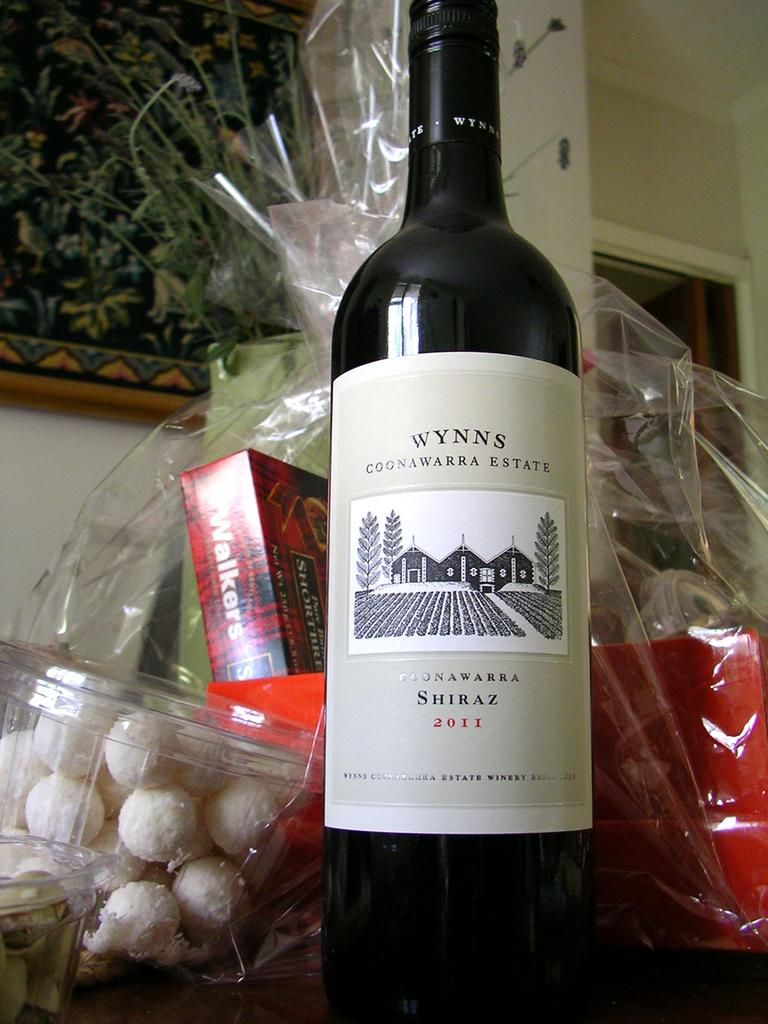<image>
Give a short and clear explanation of the subsequent image. A bottle of wine that says Wynns Coonawarra Estate is on a table with a package of goodies. 